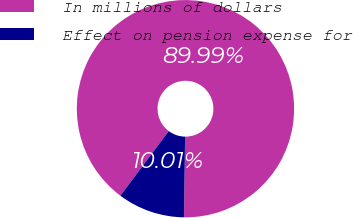Convert chart to OTSL. <chart><loc_0><loc_0><loc_500><loc_500><pie_chart><fcel>In millions of dollars<fcel>Effect on pension expense for<nl><fcel>89.99%<fcel>10.01%<nl></chart> 